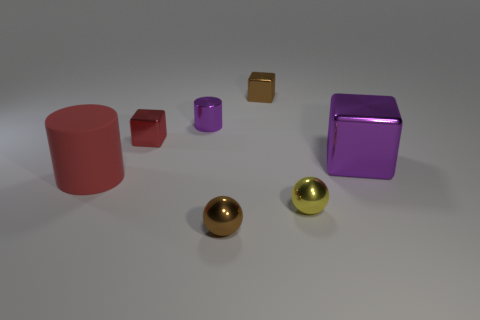Add 3 tiny blue balls. How many objects exist? 10 Subtract all balls. How many objects are left? 5 Subtract 0 red spheres. How many objects are left? 7 Subtract all big objects. Subtract all tiny metallic cubes. How many objects are left? 3 Add 1 big things. How many big things are left? 3 Add 5 small gray blocks. How many small gray blocks exist? 5 